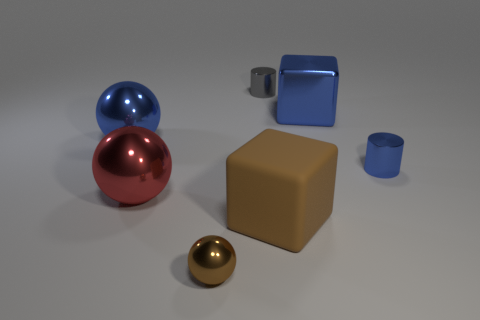What colors are present in the objects shown? The image features a palette of blue, red, brown, and gold. There's a blue sphere and a blue cup, a red sphere, a brown cube, and a gold sphere. 